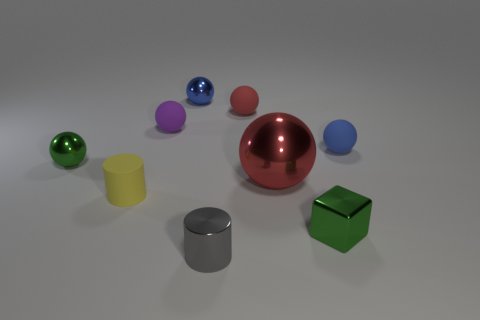Subtract all blue spheres. How many were subtracted if there are1blue spheres left? 1 Subtract all green balls. How many balls are left? 5 Subtract all tiny blue rubber balls. How many balls are left? 5 Subtract all cyan blocks. Subtract all yellow cylinders. How many blocks are left? 1 Subtract all balls. How many objects are left? 3 Add 9 tiny blocks. How many tiny blocks exist? 10 Subtract 0 cyan cubes. How many objects are left? 9 Subtract all metal spheres. Subtract all green shiny blocks. How many objects are left? 5 Add 2 green metal balls. How many green metal balls are left? 3 